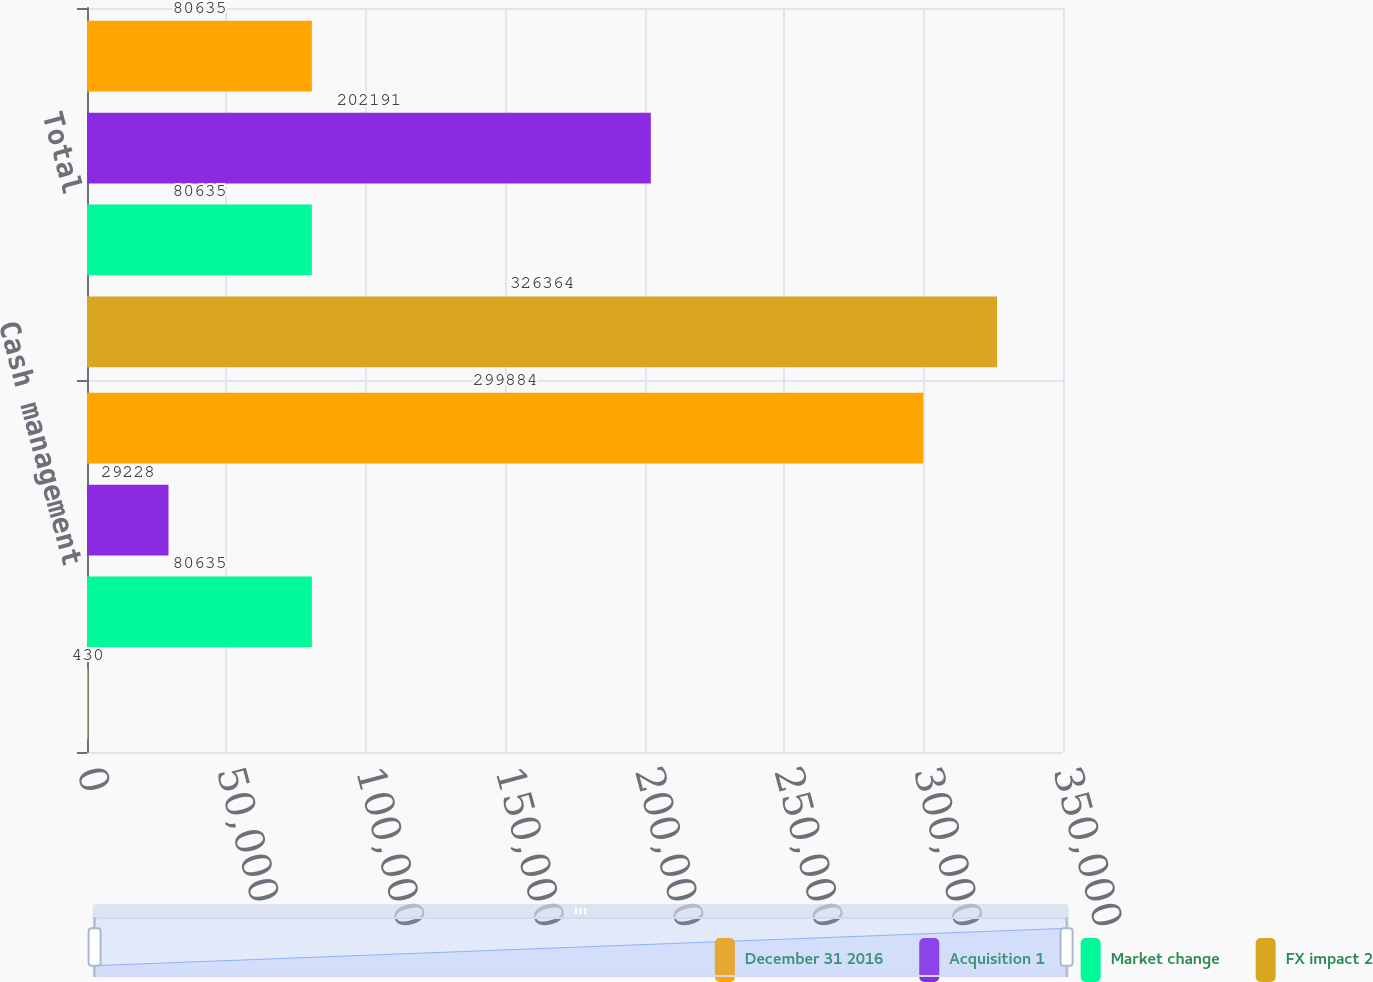Convert chart. <chart><loc_0><loc_0><loc_500><loc_500><stacked_bar_chart><ecel><fcel>Cash management<fcel>Total<nl><fcel>December 31 2016<fcel>299884<fcel>80635<nl><fcel>Acquisition 1<fcel>29228<fcel>202191<nl><fcel>Market change<fcel>80635<fcel>80635<nl><fcel>FX impact 2<fcel>430<fcel>326364<nl></chart> 